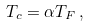Convert formula to latex. <formula><loc_0><loc_0><loc_500><loc_500>T _ { c } = \alpha T _ { F } \, ,</formula> 